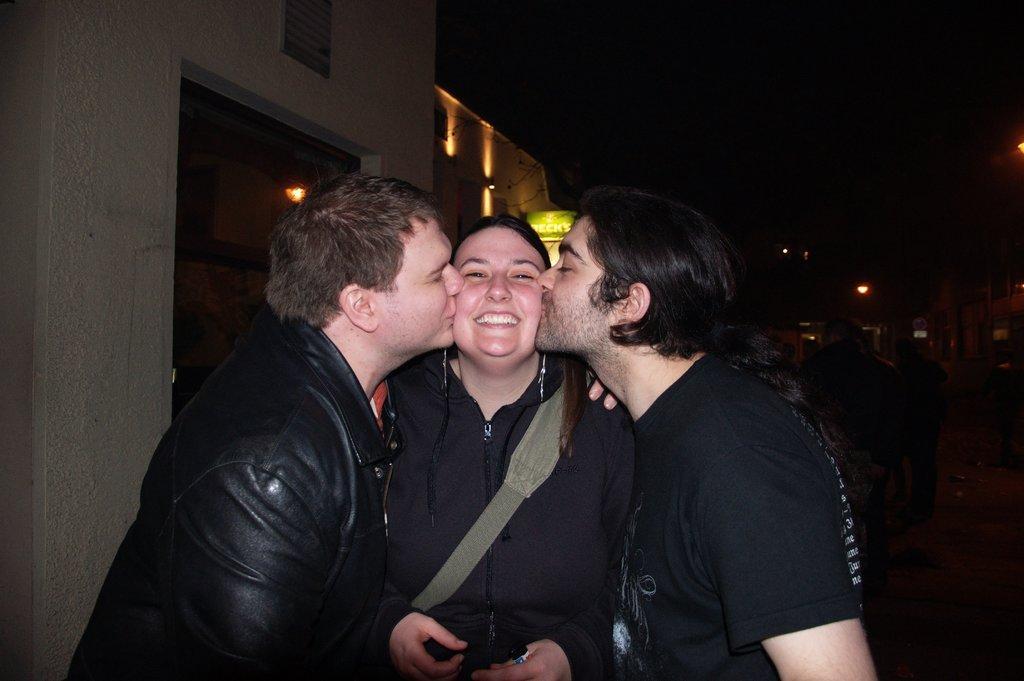In one or two sentences, can you explain what this image depicts? In this image there are 2 men standing and kissing a woman between them and the back ground there is building, lights, sky. 